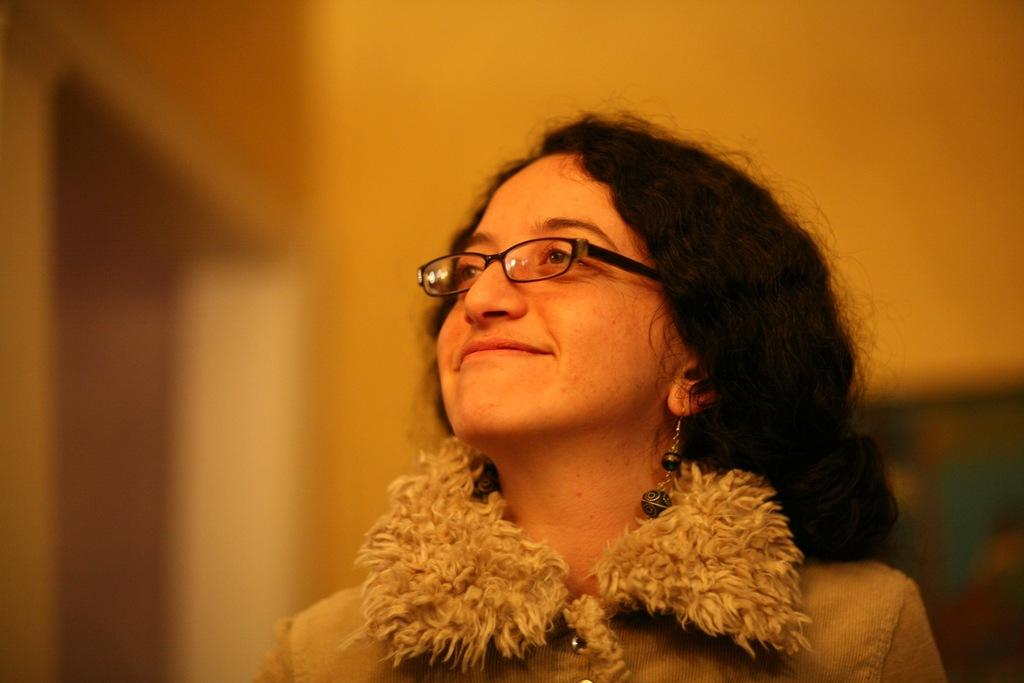What is the main subject of the image? The main subject of the image is a lady. What accessory is the lady wearing on her face? The lady is wearing specs. What type of jewelry is the lady wearing in the image? The lady is wearing earrings. How would you describe the background of the image? The background of the image is blurred. How many elbows can be seen in the image? There are no elbows visible in the image. What type of horses are depicted in the image? There are no horses present in the image. Is there any ice visible in the image? There is no ice present in the image. 